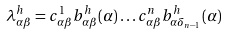<formula> <loc_0><loc_0><loc_500><loc_500>\lambda _ { \alpha \beta } ^ { h } = c _ { \alpha \beta } ^ { 1 } b ^ { h } _ { \alpha \beta } ( \alpha ) \dots c _ { \alpha \beta } ^ { n } b ^ { h } _ { \alpha \delta _ { n - 1 } } ( \alpha )</formula> 